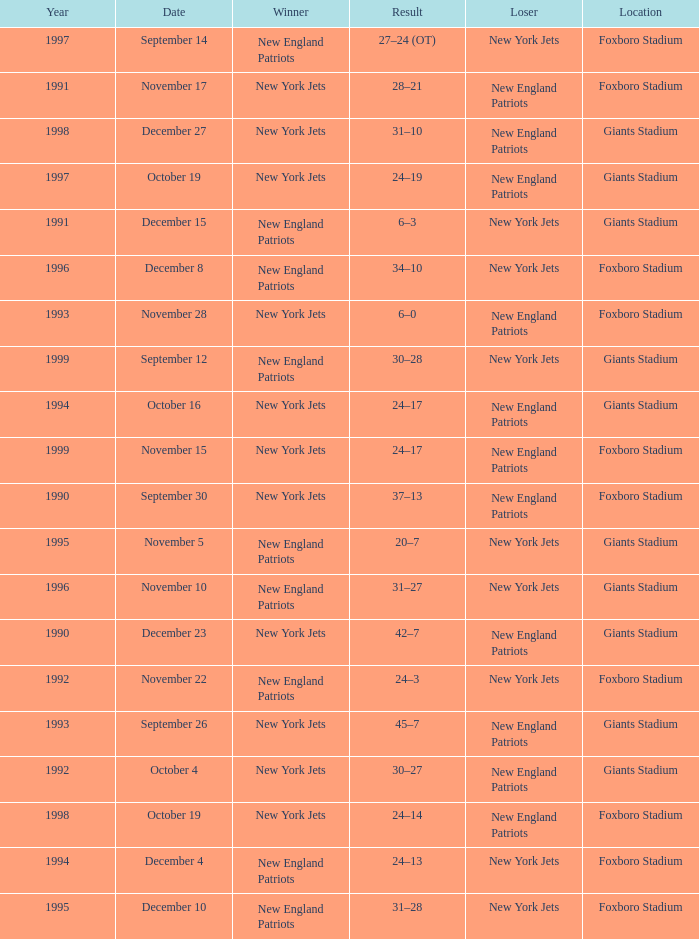What is the year when the Winner was the new york jets, with a Result of 24–17, played at giants stadium? 1994.0. 